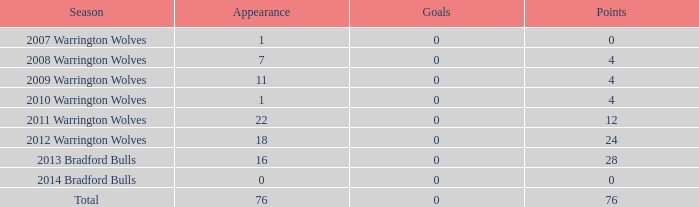How often do "tries" have a value of 0 and "appearance" is negative? 0.0. 